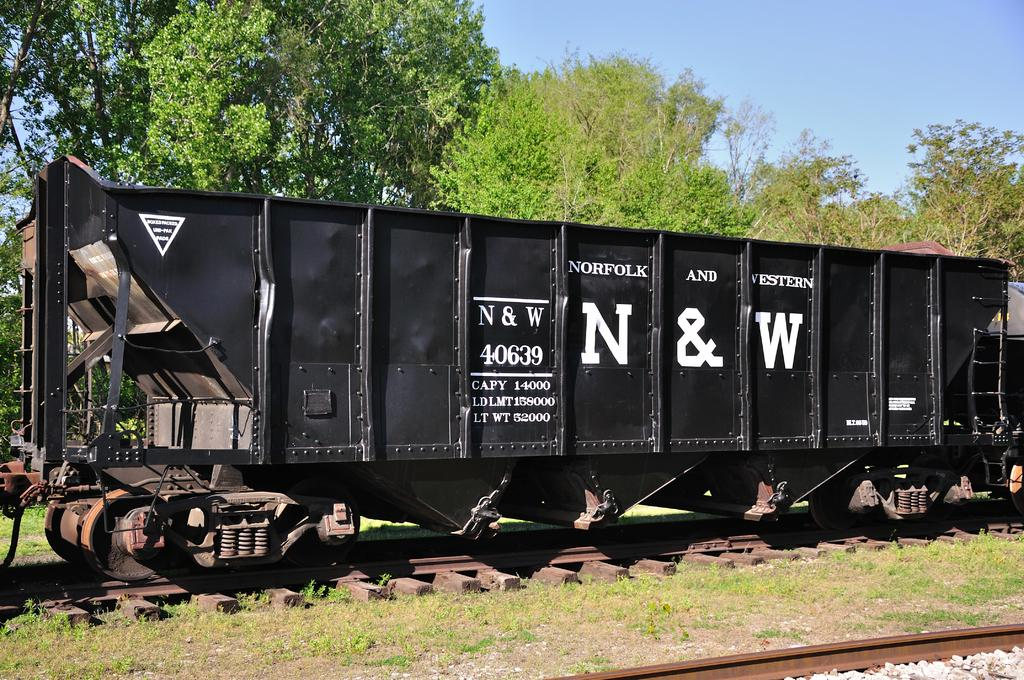What type of vehicle is in the image? There is a box car in the image. Where is the box car located? The box car is on a railway track. What can be seen in the background of the image? There are trees and the sky visible in the background of the image. What type of terrain is at the bottom of the image? There is grass at the bottom of the image. What type of soup is being served in the box car? There is no soup present in the image; it features a box car on a railway track with trees, sky, and grass in the background. 